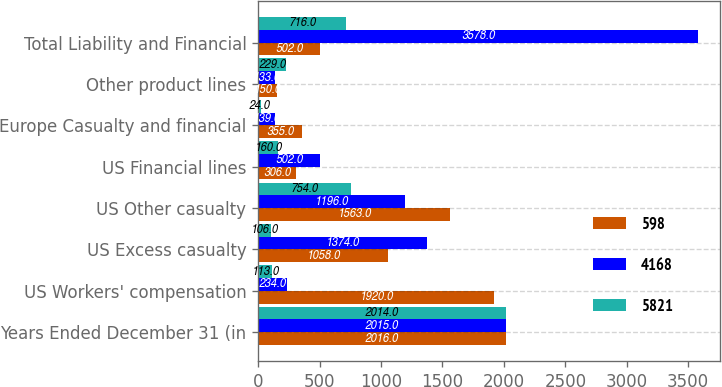<chart> <loc_0><loc_0><loc_500><loc_500><stacked_bar_chart><ecel><fcel>Years Ended December 31 (in<fcel>US Workers' compensation<fcel>US Excess casualty<fcel>US Other casualty<fcel>US Financial lines<fcel>Europe Casualty and financial<fcel>Other product lines<fcel>Total Liability and Financial<nl><fcel>598<fcel>2016<fcel>1920<fcel>1058<fcel>1563<fcel>306<fcel>355<fcel>150<fcel>502<nl><fcel>4168<fcel>2015<fcel>234<fcel>1374<fcel>1196<fcel>502<fcel>139<fcel>133<fcel>3578<nl><fcel>5821<fcel>2014<fcel>113<fcel>106<fcel>754<fcel>160<fcel>24<fcel>229<fcel>716<nl></chart> 